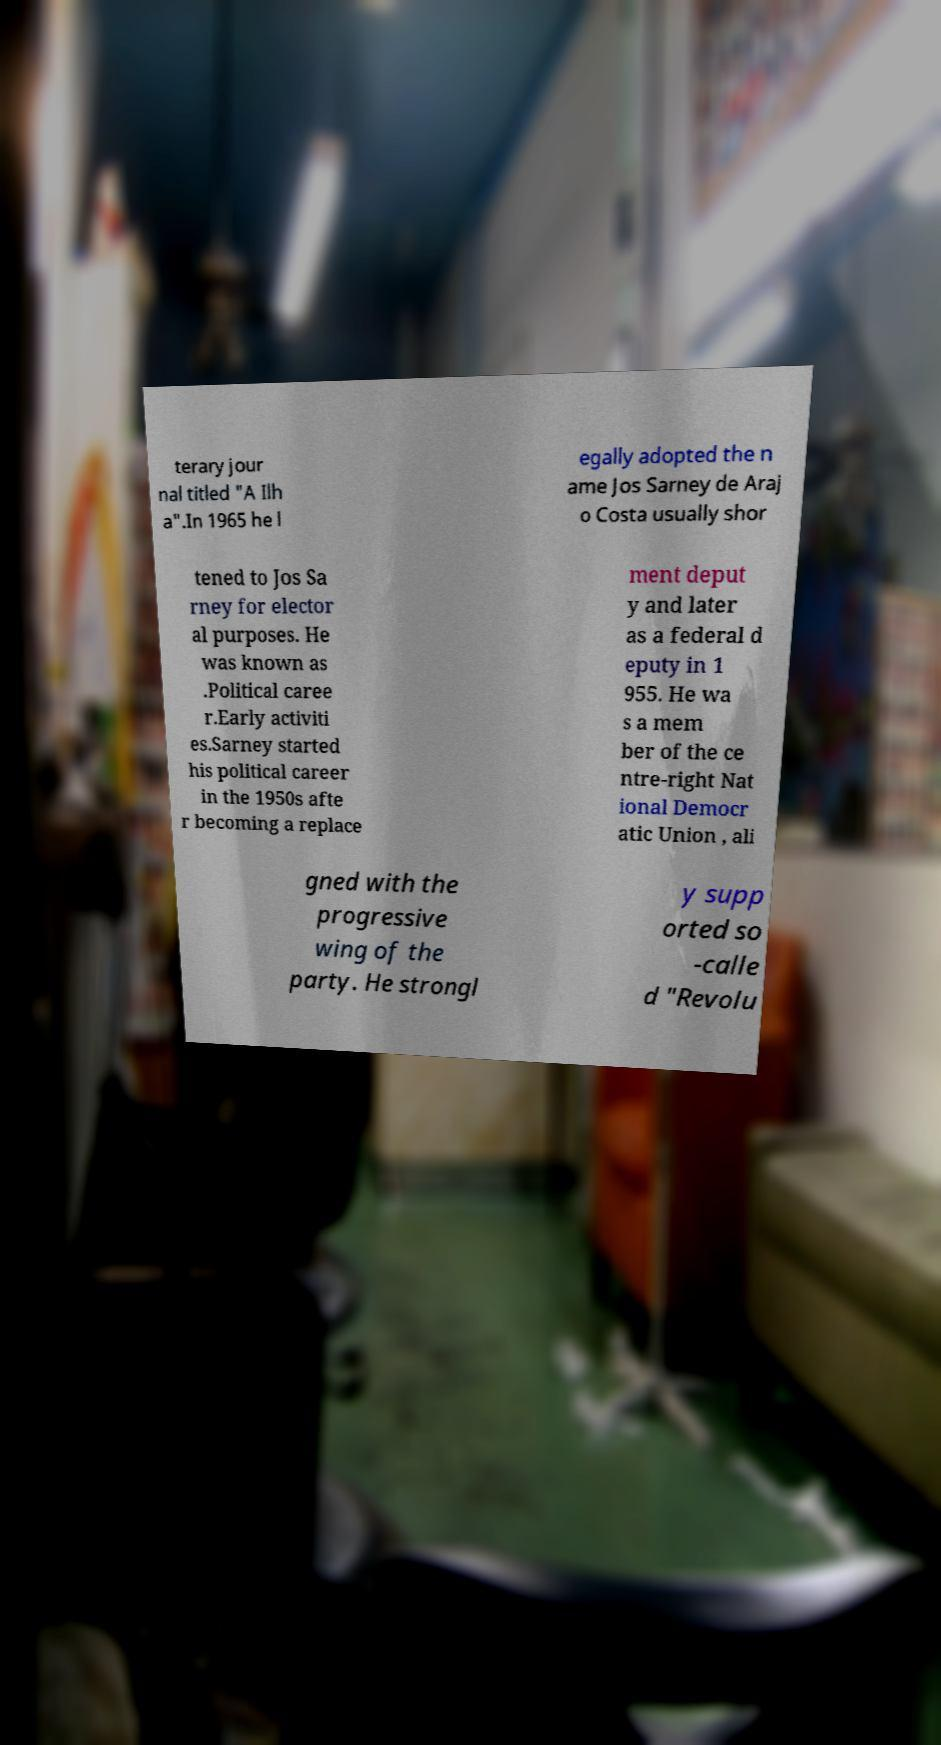Can you accurately transcribe the text from the provided image for me? terary jour nal titled "A Ilh a".In 1965 he l egally adopted the n ame Jos Sarney de Araj o Costa usually shor tened to Jos Sa rney for elector al purposes. He was known as .Political caree r.Early activiti es.Sarney started his political career in the 1950s afte r becoming a replace ment deput y and later as a federal d eputy in 1 955. He wa s a mem ber of the ce ntre-right Nat ional Democr atic Union , ali gned with the progressive wing of the party. He strongl y supp orted so -calle d "Revolu 